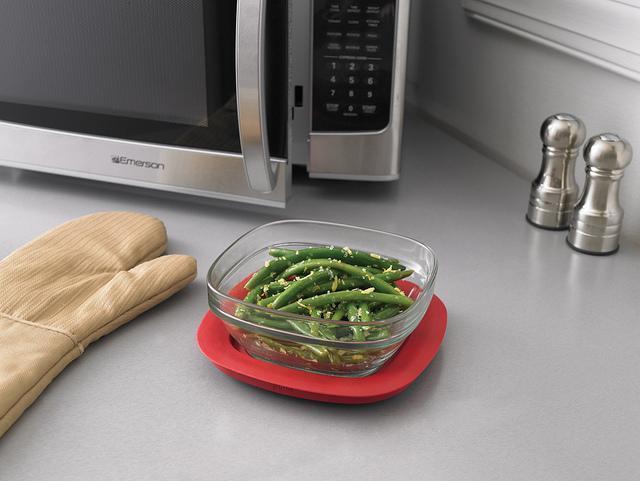How many green veggies are in the bowl?
Give a very brief answer. 1. How many red headlights does the train have?
Give a very brief answer. 0. 